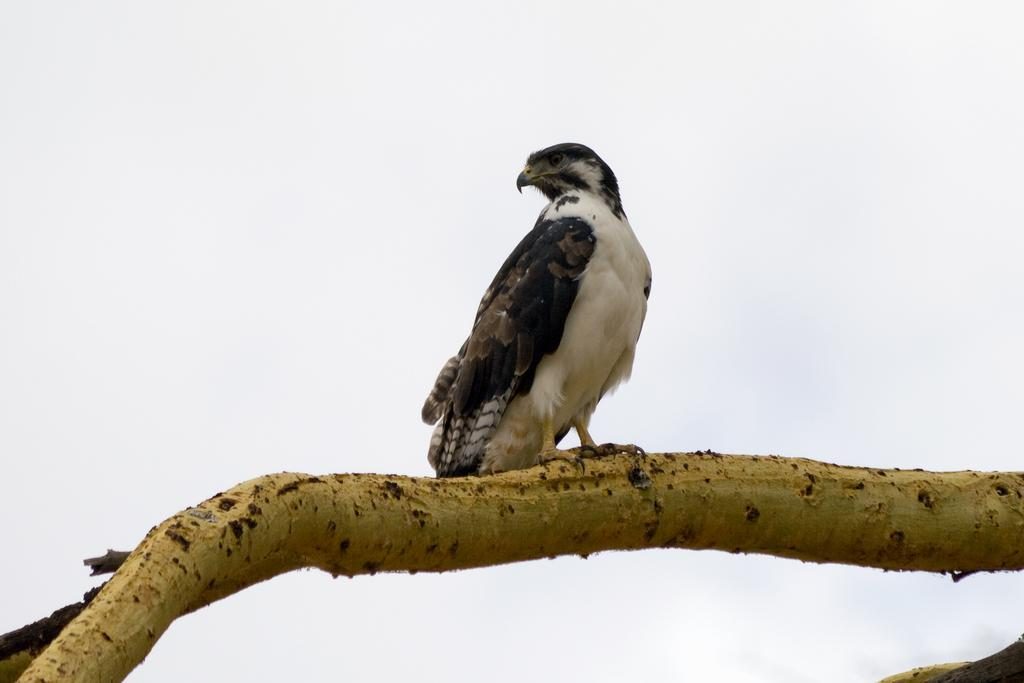What animal is featured in the image? There is an eagle in the image. Where is the eagle located in the image? The eagle is on a branch. What role does the man play in the eagle's society in the image? There is no man present in the image, and therefore no society or role for a man to play. 